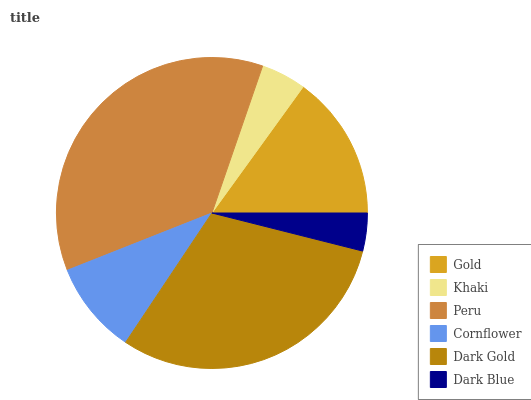Is Dark Blue the minimum?
Answer yes or no. Yes. Is Peru the maximum?
Answer yes or no. Yes. Is Khaki the minimum?
Answer yes or no. No. Is Khaki the maximum?
Answer yes or no. No. Is Gold greater than Khaki?
Answer yes or no. Yes. Is Khaki less than Gold?
Answer yes or no. Yes. Is Khaki greater than Gold?
Answer yes or no. No. Is Gold less than Khaki?
Answer yes or no. No. Is Gold the high median?
Answer yes or no. Yes. Is Cornflower the low median?
Answer yes or no. Yes. Is Khaki the high median?
Answer yes or no. No. Is Dark Gold the low median?
Answer yes or no. No. 